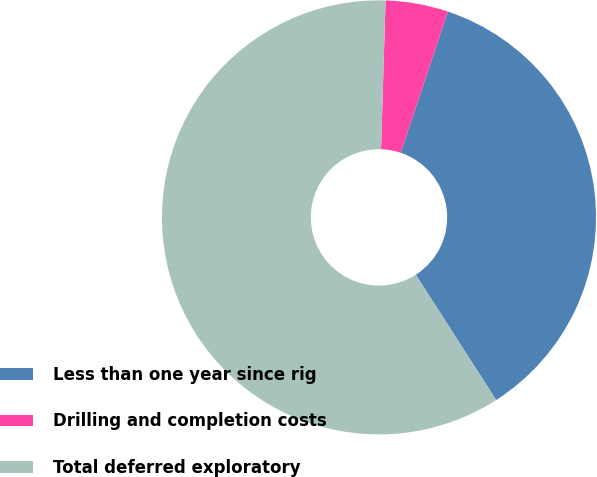<chart> <loc_0><loc_0><loc_500><loc_500><pie_chart><fcel>Less than one year since rig<fcel>Drilling and completion costs<fcel>Total deferred exploratory<nl><fcel>35.78%<fcel>4.66%<fcel>59.56%<nl></chart> 